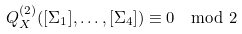Convert formula to latex. <formula><loc_0><loc_0><loc_500><loc_500>Q _ { X } ^ { ( 2 ) } ( [ \Sigma _ { 1 } ] , \dots , [ \Sigma _ { 4 } ] ) \equiv 0 \mod 2</formula> 